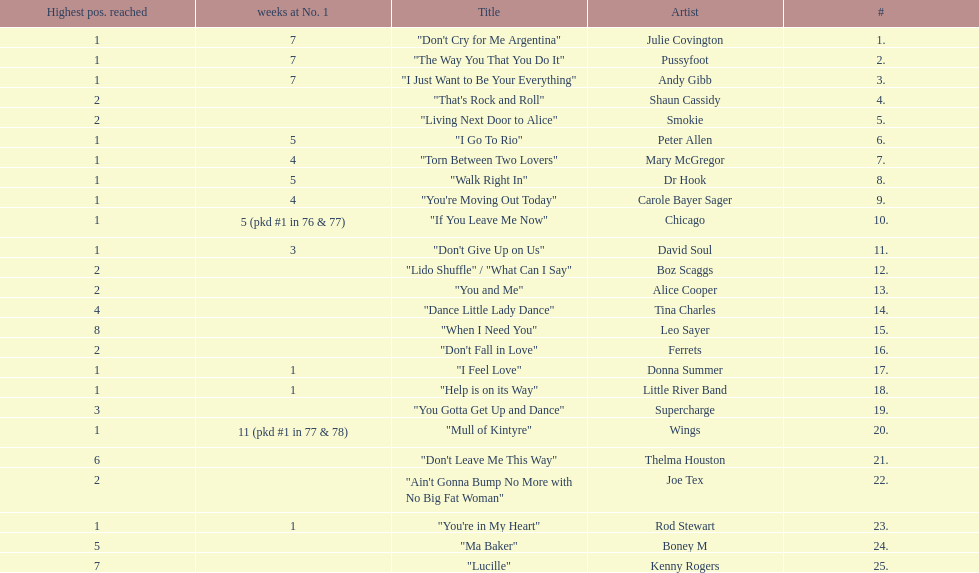How many weeks did julie covington's "don't cry for me argentina" spend at the top of australia's singles chart? 7. 